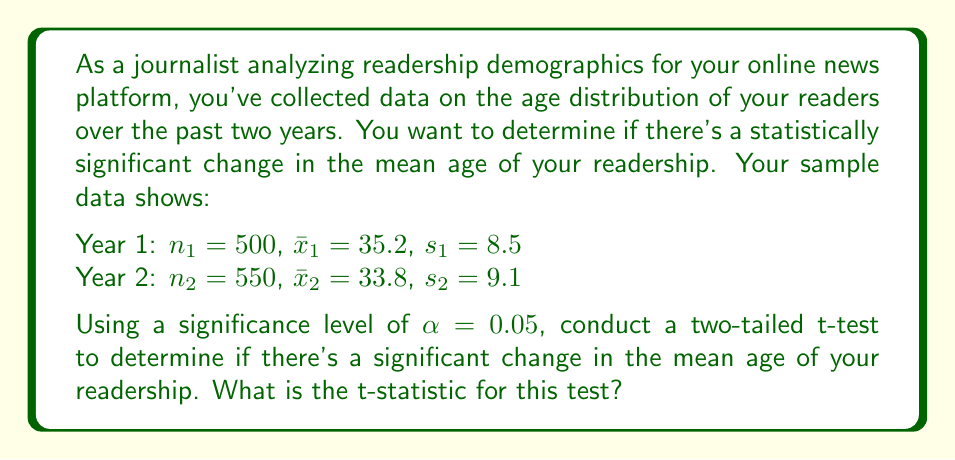Can you solve this math problem? To determine if there's a statistically significant change in the mean age of the readership, we'll use an independent samples t-test. The steps are as follows:

1) First, we need to calculate the pooled standard deviation:

   $s_p = \sqrt{\frac{(n_1 - 1)s_1^2 + (n_2 - 1)s_2^2}{n_1 + n_2 - 2}}$

   $s_p = \sqrt{\frac{(500 - 1)(8.5)^2 + (550 - 1)(9.1)^2}{500 + 550 - 2}}$

   $s_p = \sqrt{\frac{36125.25 + 45540.09}{1048}} = \sqrt{78.0012} = 8.832$

2) Now we can calculate the t-statistic:

   $t = \frac{\bar{x}_1 - \bar{x}_2}{s_p \sqrt{\frac{1}{n_1} + \frac{1}{n_2}}}$

   $t = \frac{35.2 - 33.8}{8.832 \sqrt{\frac{1}{500} + \frac{1}{550}}}$

   $t = \frac{1.4}{8.832 \sqrt{0.002 + 0.00182}} = \frac{1.4}{8.832 \sqrt{0.00382}}$

   $t = \frac{1.4}{8.832 * 0.0618} = \frac{1.4}{0.546}$

   $t = 2.564$

Therefore, the t-statistic for this test is 2.564.
Answer: $t = 2.564$ 